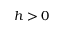Convert formula to latex. <formula><loc_0><loc_0><loc_500><loc_500>h > 0</formula> 